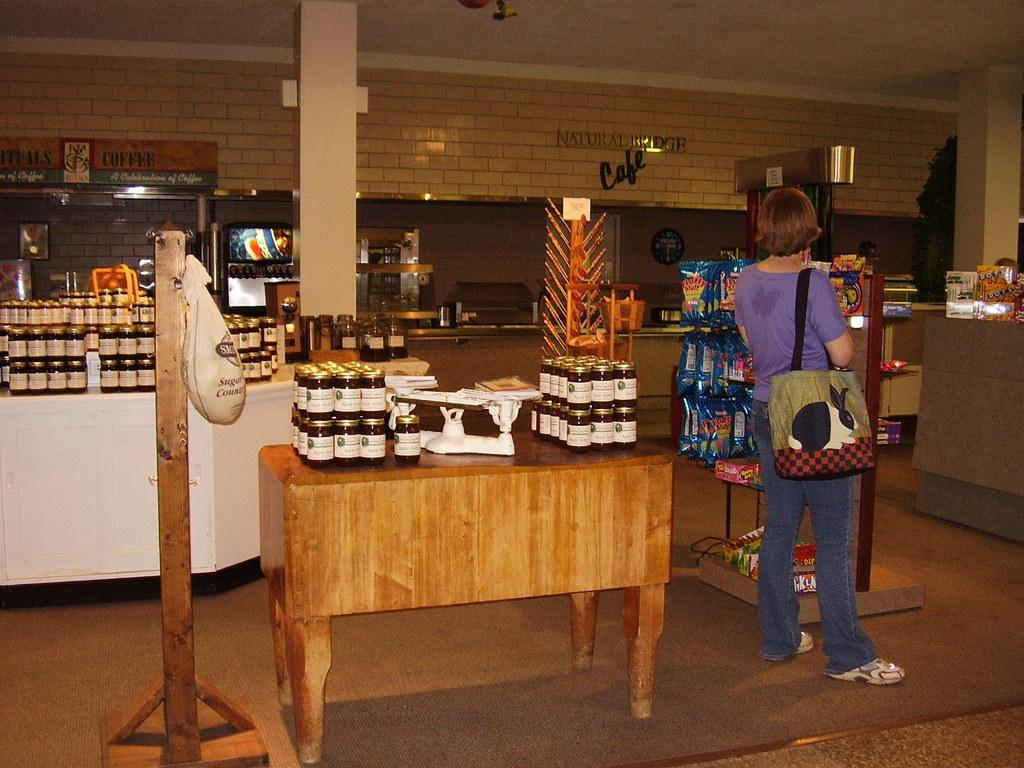What is the main setting of the image? The image depicts a room. What objects can be seen on a table in the room? There are bottles on a table in the room. What is the position of the woman in the image? A woman is standing on the floor in the room. What type of calendar is hanging on the wall in the image? There is no calendar present in the image. What noise can be heard coming from the quiver in the image? There is no quiver present in the image, and therefore no noise can be heard from it. 